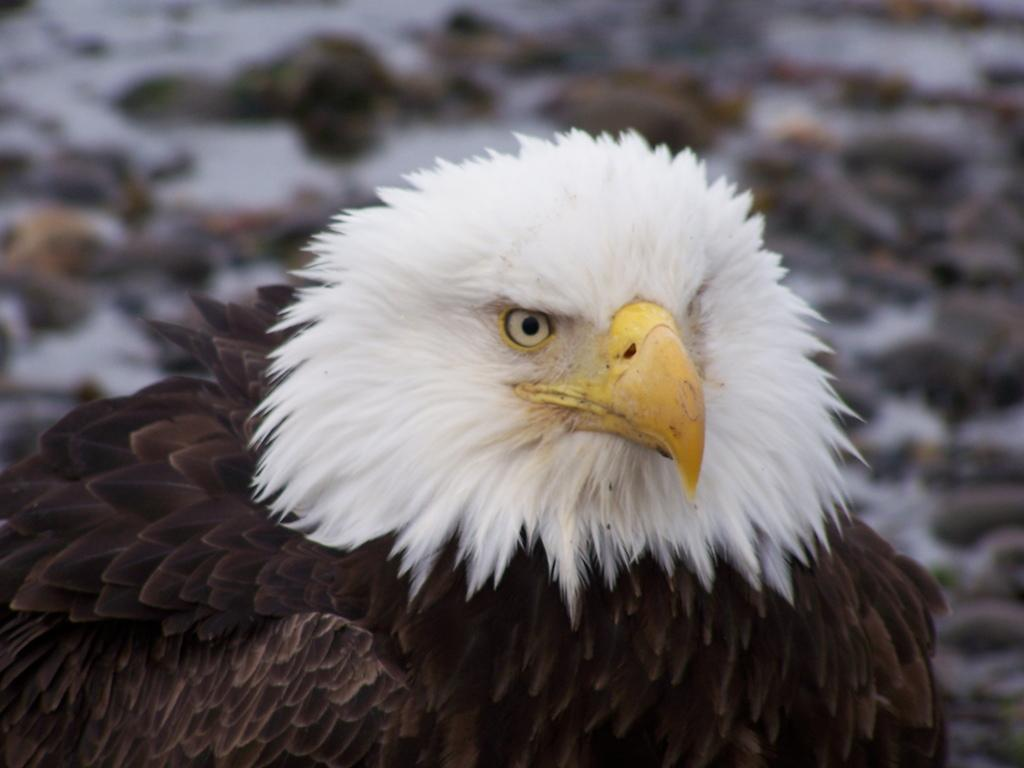What animal is the main subject of the picture? There is an eagle in the picture. Can you describe the background of the image? The background of the image is blurred. What type of laborer can be seen working in the alley during recess in the image? There is no laborer, alley, or recess present in the image; it features an eagle with a blurred background. 